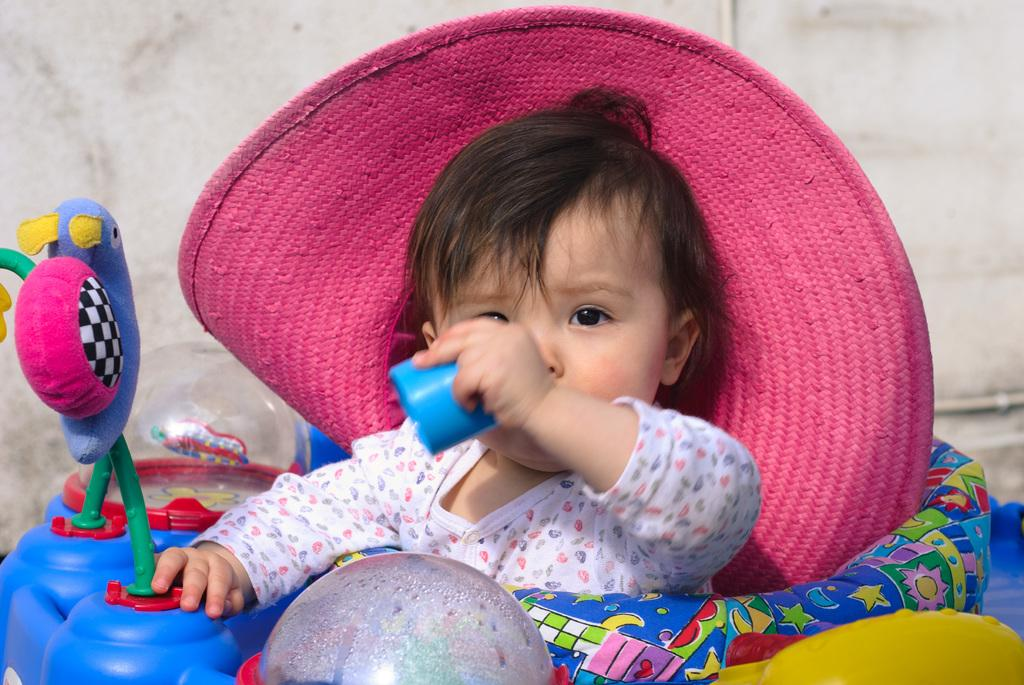What is the main subject of the image? The main subject of the image is a kid. What is the kid doing in the image? The kid is sitting on a toy. What accessory is the kid wearing? The kid is wearing a hat. What can be seen in the background of the image? There is a wall in the background of the image. What type of invention is the kid using to light up the room in the image? There is no invention or light source mentioned in the image; it only features a kid sitting on a toy and wearing a hat. Can you tell me how many bulbs are visible in the image? There are no bulbs present in the image. 